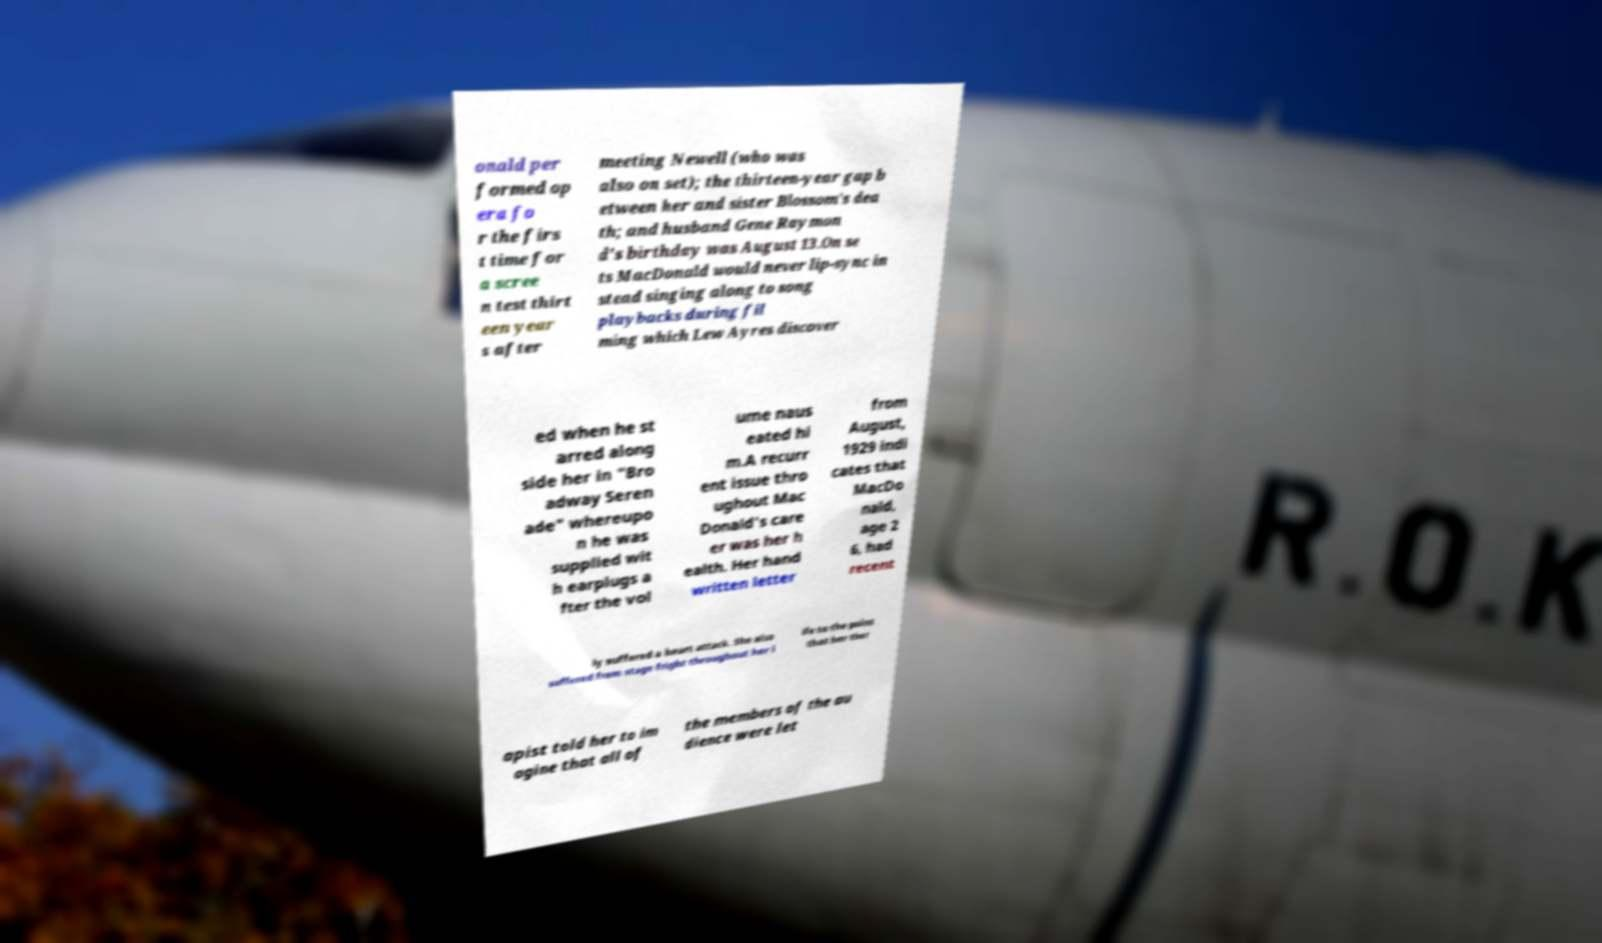Please read and relay the text visible in this image. What does it say? onald per formed op era fo r the firs t time for a scree n test thirt een year s after meeting Newell (who was also on set); the thirteen-year gap b etween her and sister Blossom's dea th; and husband Gene Raymon d's birthday was August 13.On se ts MacDonald would never lip-sync in stead singing along to song playbacks during fil ming which Lew Ayres discover ed when he st arred along side her in "Bro adway Seren ade" whereupo n he was supplied wit h earplugs a fter the vol ume naus eated hi m.A recurr ent issue thro ughout Mac Donald's care er was her h ealth. Her hand written letter from August, 1929 indi cates that MacDo nald, age 2 6, had recent ly suffered a heart attack. She also suffered from stage fright throughout her l ife to the point that her ther apist told her to im agine that all of the members of the au dience were let 